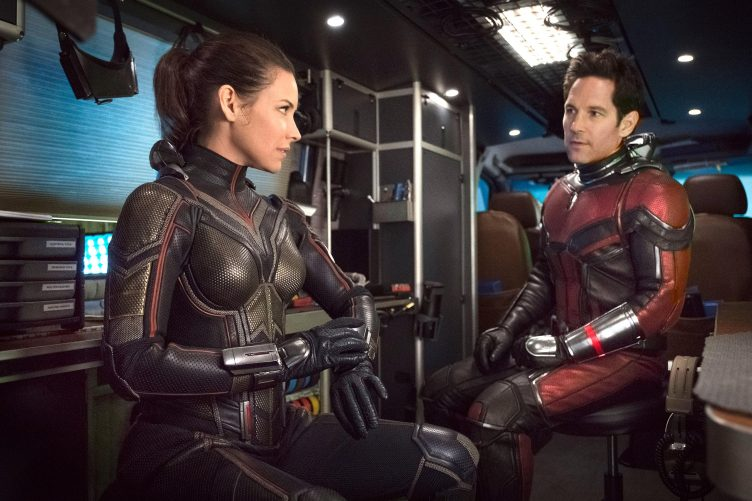How do the costumes of the characters contribute to the storytelling in this movie? The costumes of the characters are meticulously designed to reflect their superhero identities and enhance the storytelling. The Wasp's suit, with its sleek, armor-like appearance and hints of silver, signifies agility and combat readiness, emphasizing her as a formidable force. Ant-Man's suit, while also robust, has a slightly bulkier design which complements his ability to change size and strength dynamically. Each costume not only serves a practical function within the narrative, protecting each character and aiding in their abilities, but also visually conveys their unique heroics and personalities. 